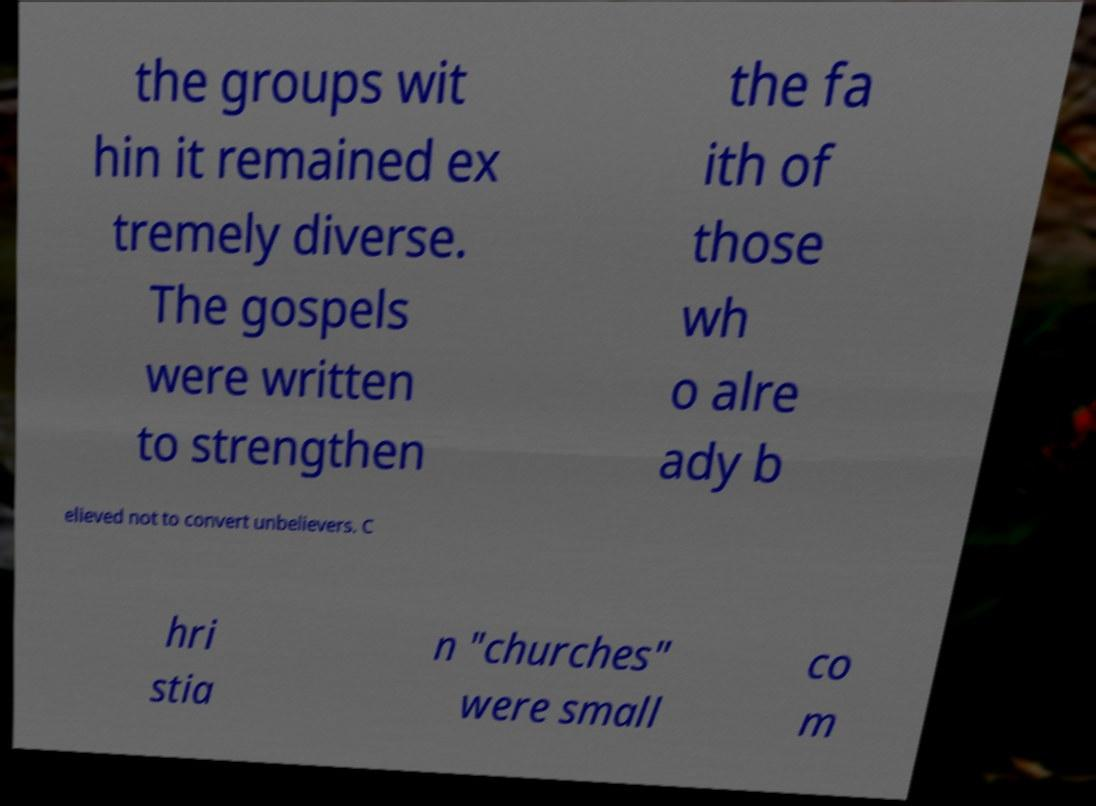Could you extract and type out the text from this image? the groups wit hin it remained ex tremely diverse. The gospels were written to strengthen the fa ith of those wh o alre ady b elieved not to convert unbelievers. C hri stia n "churches" were small co m 